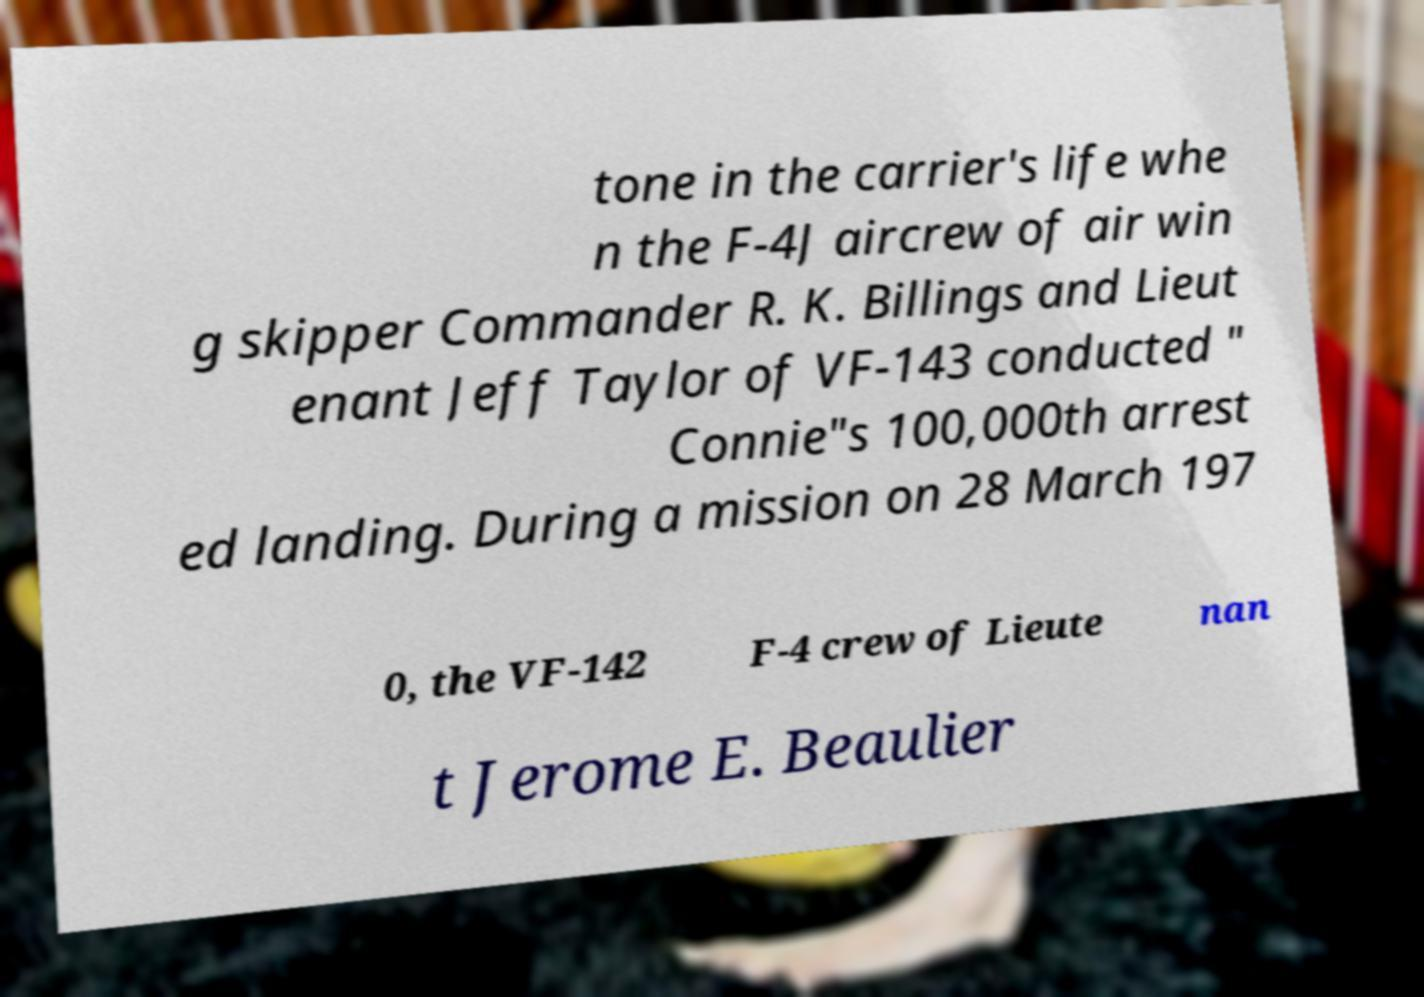Can you read and provide the text displayed in the image?This photo seems to have some interesting text. Can you extract and type it out for me? tone in the carrier's life whe n the F-4J aircrew of air win g skipper Commander R. K. Billings and Lieut enant Jeff Taylor of VF-143 conducted " Connie"s 100,000th arrest ed landing. During a mission on 28 March 197 0, the VF-142 F-4 crew of Lieute nan t Jerome E. Beaulier 